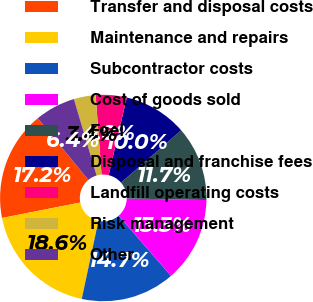<chart> <loc_0><loc_0><loc_500><loc_500><pie_chart><fcel>Transfer and disposal costs<fcel>Maintenance and repairs<fcel>Subcontractor costs<fcel>Cost of goods sold<fcel>Fuel<fcel>Disposal and franchise fees<fcel>Landfill operating costs<fcel>Risk management<fcel>Other<nl><fcel>17.15%<fcel>18.56%<fcel>14.74%<fcel>13.29%<fcel>11.7%<fcel>9.95%<fcel>4.84%<fcel>3.42%<fcel>6.35%<nl></chart> 